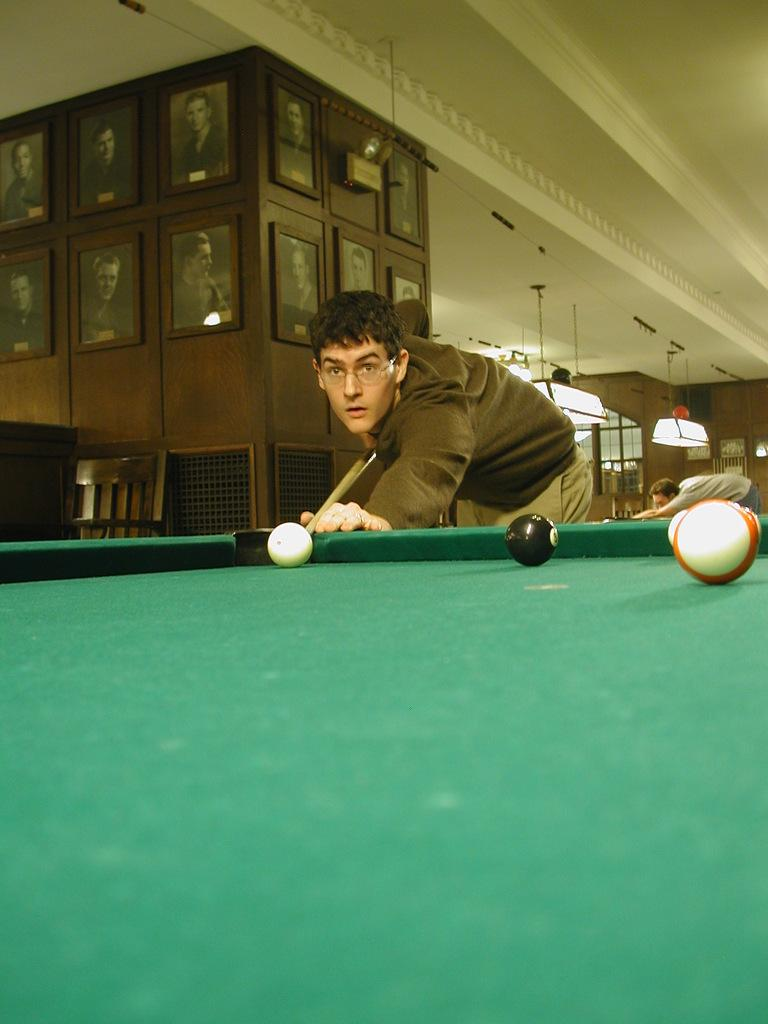What is the man in the image holding? The man is holding a stick in the image. What is the man doing with the stick? The man is hitting a ball with the stick. What type of surface can be seen in the image? There are balls on a tennis table in the image. What type of structure is present in the image? There are frames in the image. How many people are in the image? There are two men in the image. What is the source of illumination in the image? There is light in the image. What type of furniture is present in the image? There is a chair in the image. How many patches are on the chair in the image? There are no patches mentioned or visible on the chair in the image. 